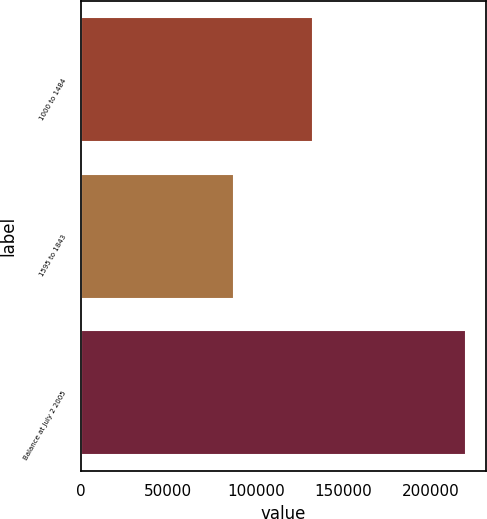Convert chart to OTSL. <chart><loc_0><loc_0><loc_500><loc_500><bar_chart><fcel>1000 to 1484<fcel>1595 to 1843<fcel>Balance at July 2 2005<nl><fcel>132634<fcel>87681<fcel>220315<nl></chart> 